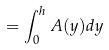<formula> <loc_0><loc_0><loc_500><loc_500>= \int _ { 0 } ^ { h } A ( y ) d y</formula> 